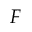<formula> <loc_0><loc_0><loc_500><loc_500>F</formula> 